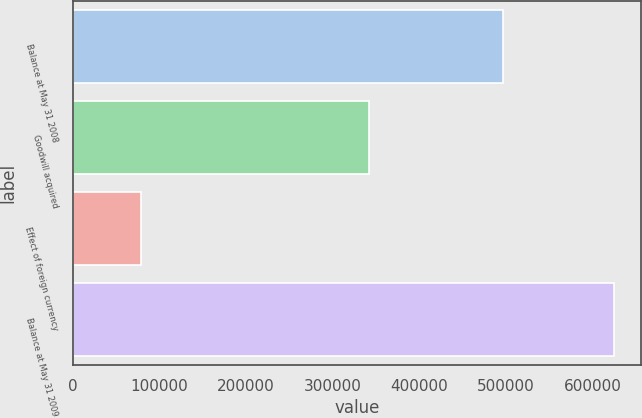<chart> <loc_0><loc_0><loc_500><loc_500><bar_chart><fcel>Balance at May 31 2008<fcel>Goodwill acquired<fcel>Effect of foreign currency<fcel>Balance at May 31 2009<nl><fcel>497136<fcel>341928<fcel>78859<fcel>625120<nl></chart> 